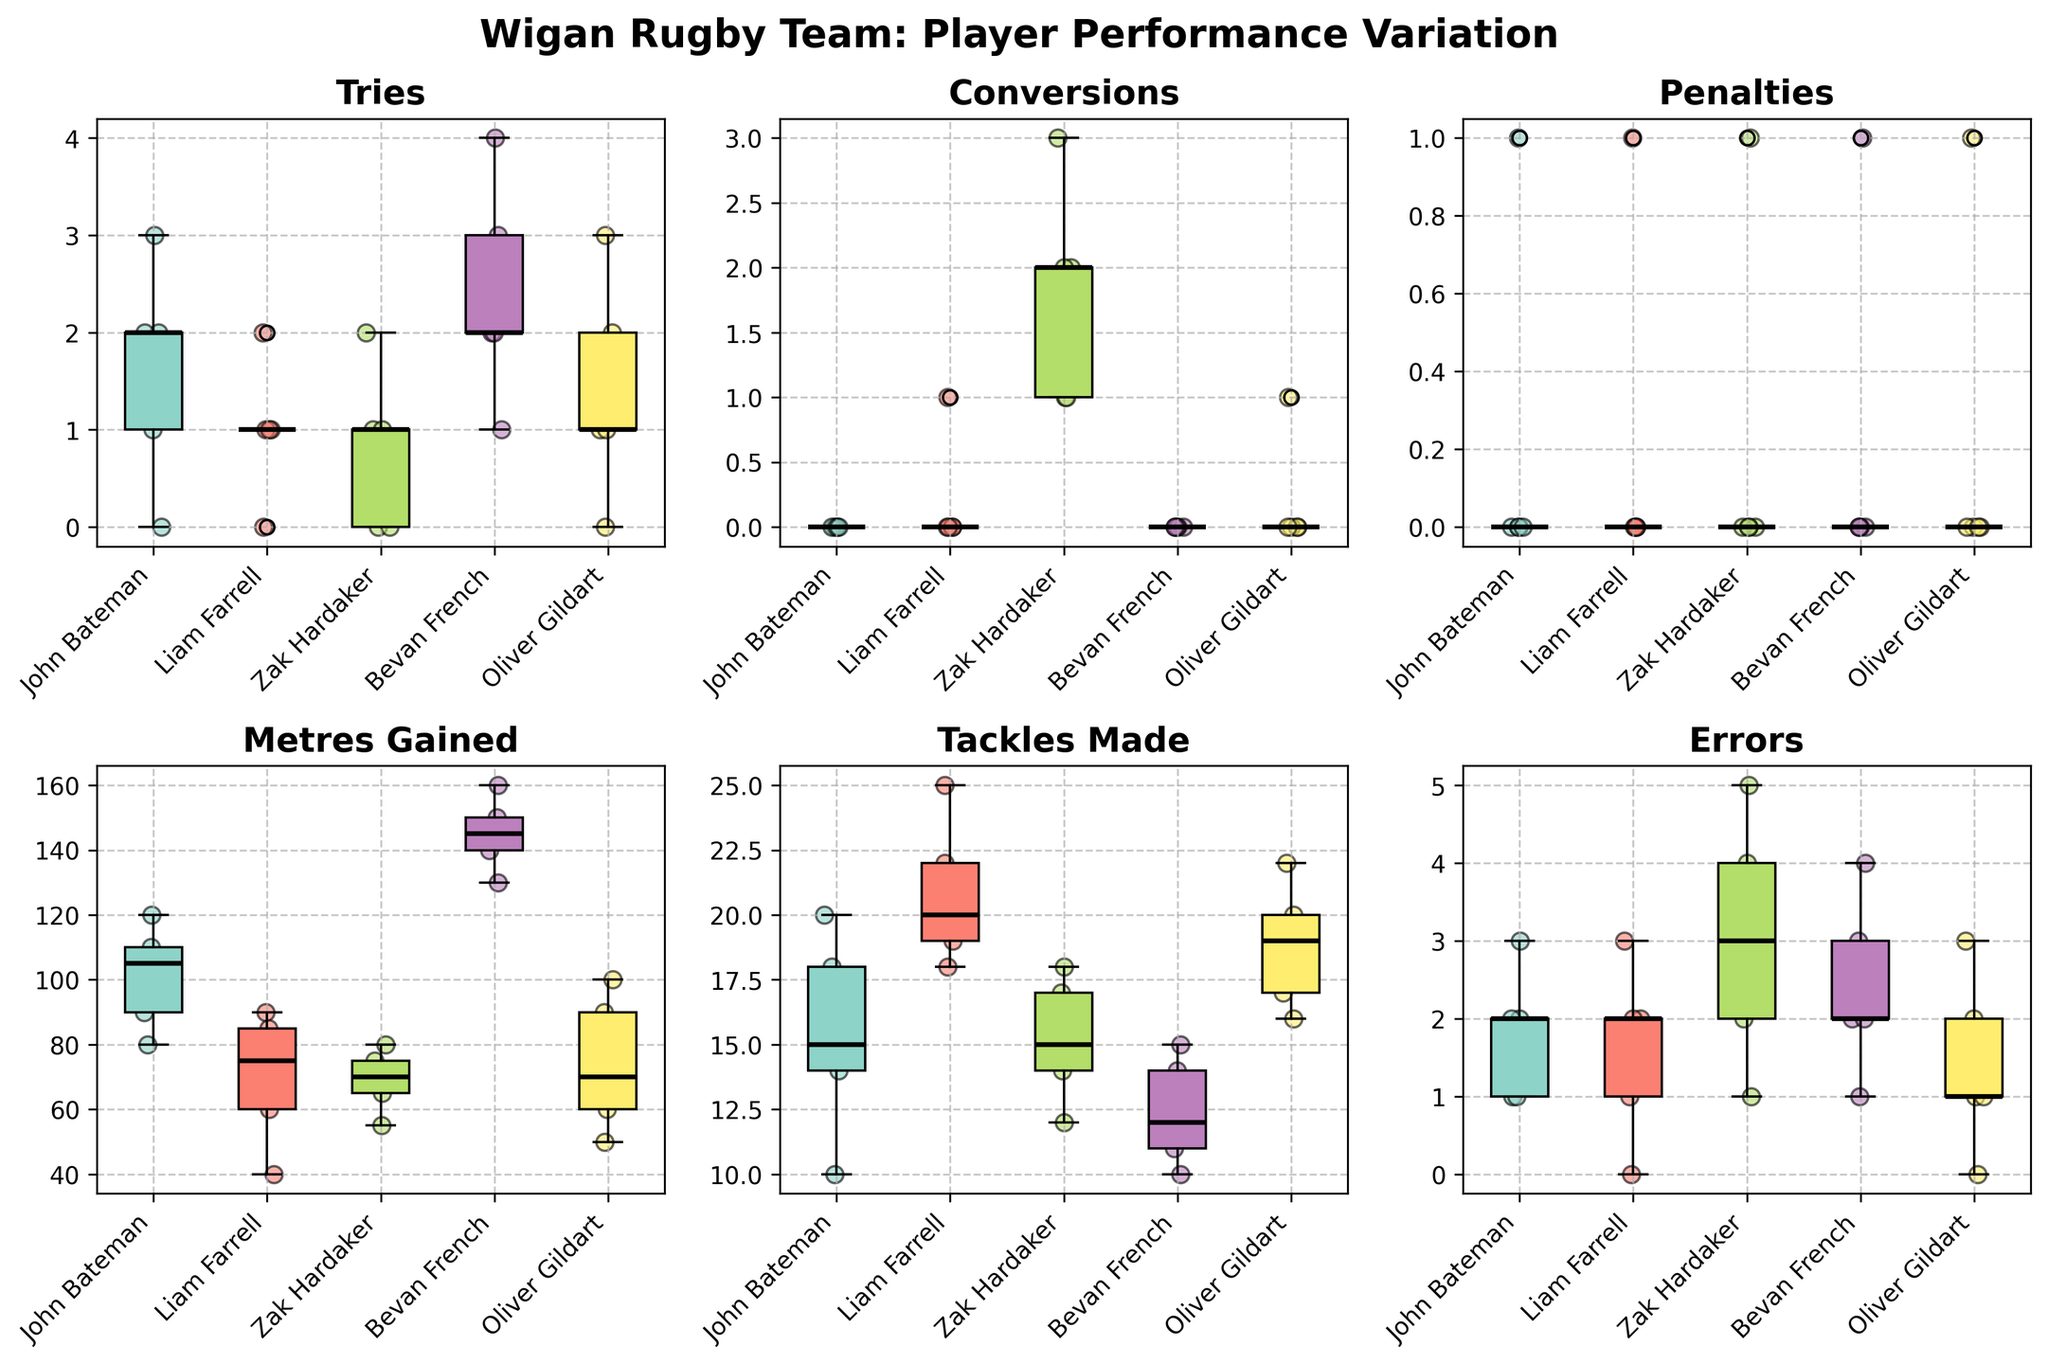How many players are represented in the figure? Count the unique players on the x-axis in each subplot. There are 5 different players: John Bateman, Liam Farrell, Zak Hardaker, Bevan French, and Oliver Gildart.
Answer: 5 Which player scored the most tries in a single match? Look at the scatter points for the 'Tries' subplot and identify the highest single value. Bevan French scored 4 tries in one match.
Answer: Bevan French What is the range of tries scored by John Bateman? The range is the difference between the maximum and minimum values of the tries scored by John Bateman in the 'Tries' subplot. The tries range from 0 to 3.
Answer: 3 Who made the most tackles in a single match? The 'Tackles Made' subplot shows individual data points. Liam Farrell made the most tackles in a single match, with 25 tackles.
Answer: Liam Farrell Which player has the highest median value for 'Metres Gained'? Observe the position of the median line in the 'Metres Gained' subplot. Bevan French has the highest median value.
Answer: Bevan French Which metric shows the greatest variation for Zak Hardaker? Look at the width and spread of the boxplots for Zak Hardaker in each subplot. The 'Errors' subplot shows significant variation for Zak Hardaker.
Answer: Errors What is the median number of penalties for Oliver Gildart? The median line of the boxplot in the 'Penalties' subplot for Oliver Gildart is at 0.
Answer: 0 Do more players have higher median ‘Tries’ or ‘Conversions’ scores? Compare the median lines in the 'Tries' and 'Conversions' subplots across all players. More players have higher median ‘Tries’ scores.
Answer: Tries Which player has the lowest maximum value for 'Meters Gained'? Identify the maximum values in the 'Meters Gained' subplot for each player. Zak Hardaker has the lowest maximum value.
Answer: Zak Hardaker Are errors more consistent for Liam Farrell or Zak Hardaker? Compare the width and spread of the boxplots in the 'Errors' subplot for both players. Liam Farrell's errors are more consistent, showing a narrower interquartile range.
Answer: Liam Farrell 